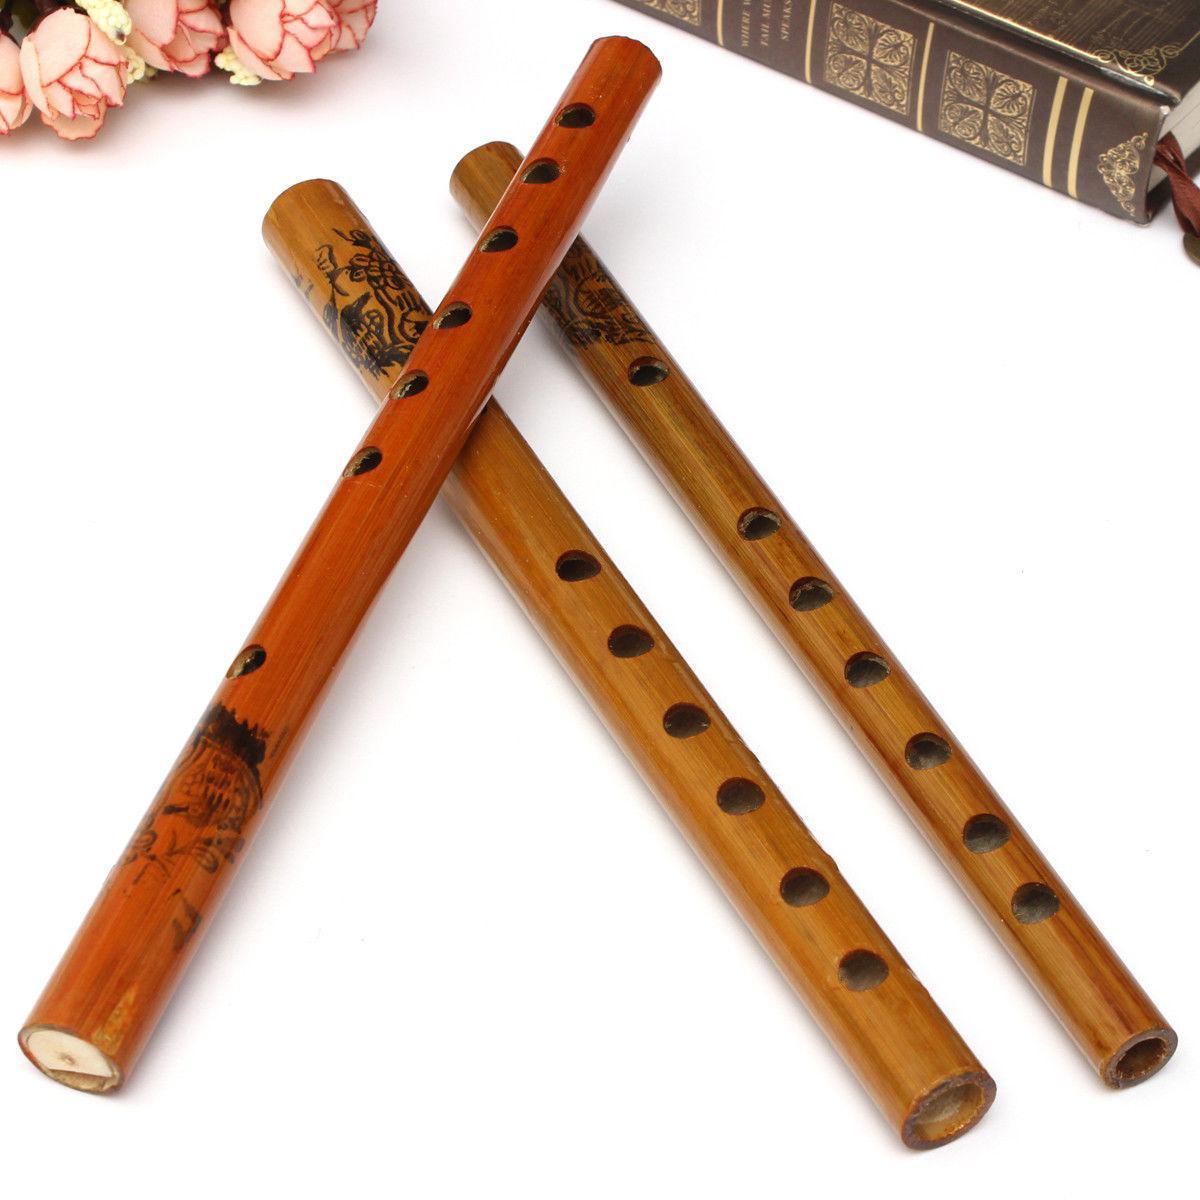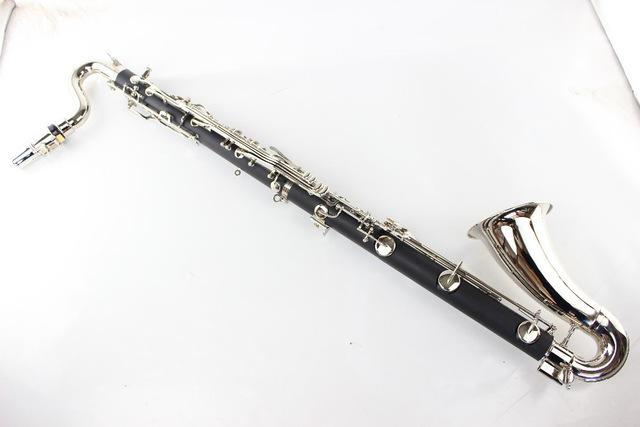The first image is the image on the left, the second image is the image on the right. Evaluate the accuracy of this statement regarding the images: "The combined images contain one straight black flute with a flared end, one complete wooden flute, and two flute pieces displayed with one end close together.". Is it true? Answer yes or no. No. The first image is the image on the left, the second image is the image on the right. Analyze the images presented: Is the assertion "There are exactly four wooden cylinders." valid? Answer yes or no. No. 